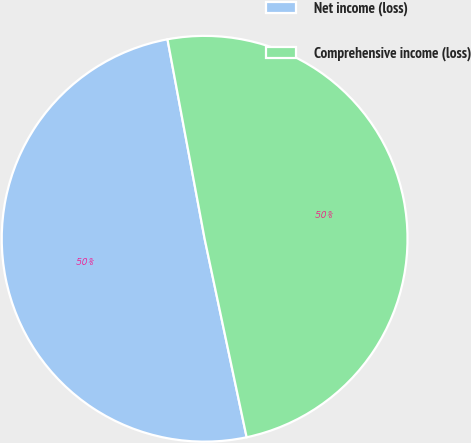<chart> <loc_0><loc_0><loc_500><loc_500><pie_chart><fcel>Net income (loss)<fcel>Comprehensive income (loss)<nl><fcel>50.39%<fcel>49.61%<nl></chart> 